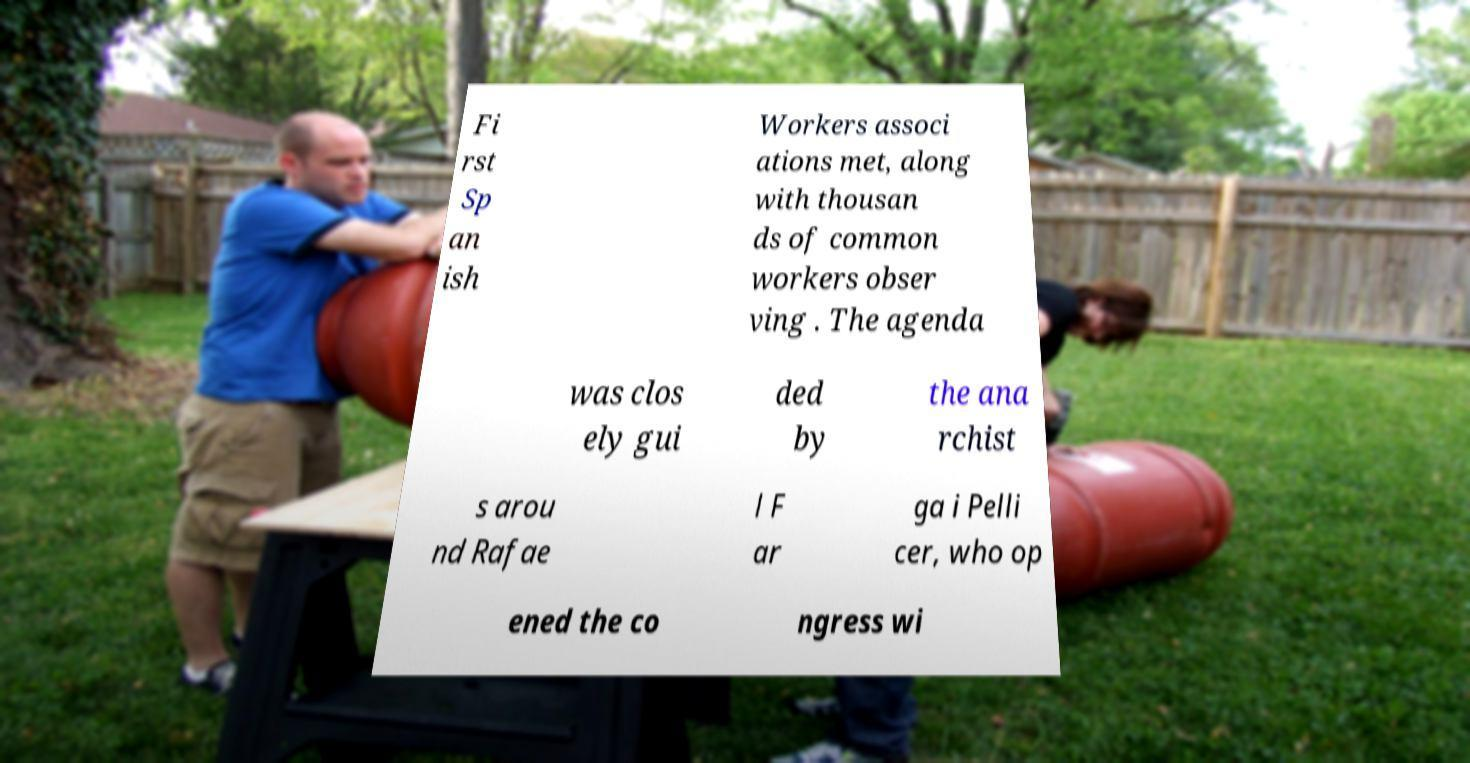Please identify and transcribe the text found in this image. Fi rst Sp an ish Workers associ ations met, along with thousan ds of common workers obser ving . The agenda was clos ely gui ded by the ana rchist s arou nd Rafae l F ar ga i Pelli cer, who op ened the co ngress wi 